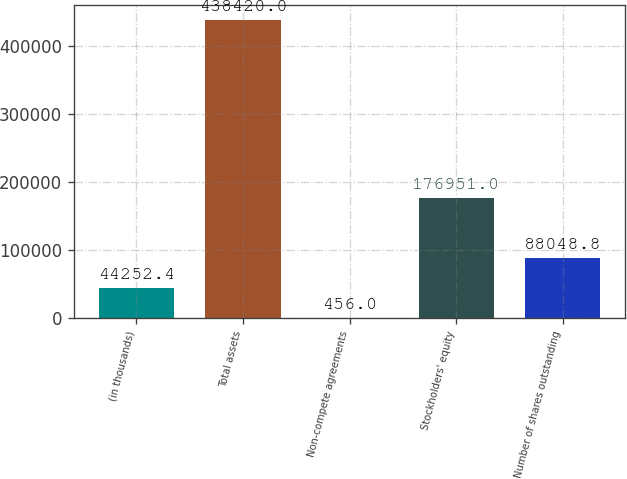Convert chart to OTSL. <chart><loc_0><loc_0><loc_500><loc_500><bar_chart><fcel>(in thousands)<fcel>Total assets<fcel>Non-compete agreements<fcel>Stockholders' equity<fcel>Number of shares outstanding<nl><fcel>44252.4<fcel>438420<fcel>456<fcel>176951<fcel>88048.8<nl></chart> 